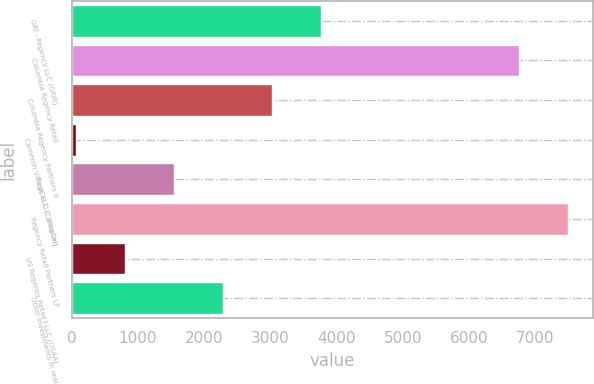<chart> <loc_0><loc_0><loc_500><loc_500><bar_chart><fcel>GRI - Regency LLC (GRIR)<fcel>Columbia Regency Retail<fcel>Columbia Regency Partners II<fcel>Cameron Village LLC (Cameron)<fcel>RegCal LLC (RegCal)<fcel>Regency Retail Partners LP<fcel>US Regency Retail I LLC (USAA)<fcel>Other investments in real<nl><fcel>3759<fcel>6753<fcel>3020.4<fcel>66<fcel>1543.2<fcel>7491.6<fcel>804.6<fcel>2281.8<nl></chart> 